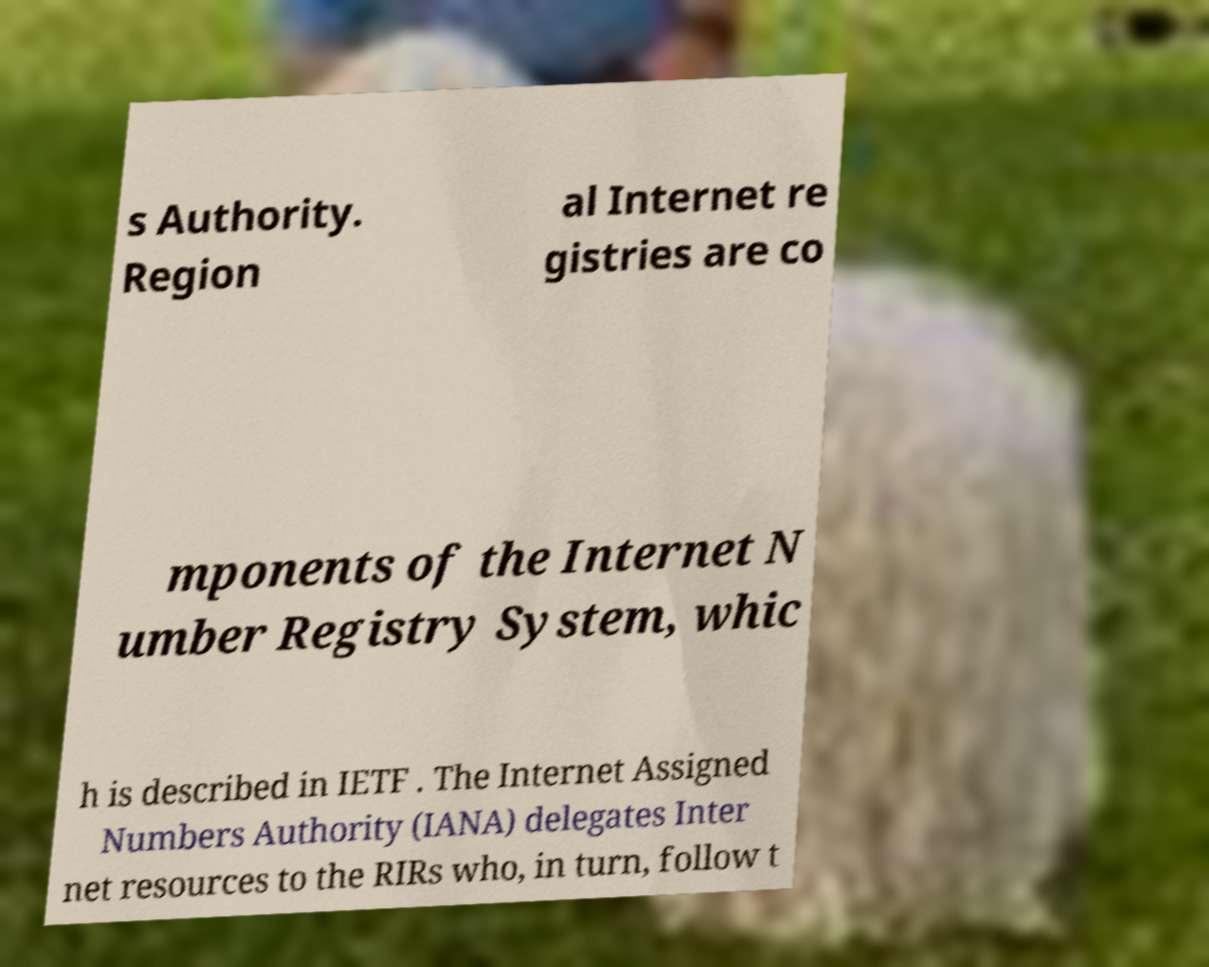Can you read and provide the text displayed in the image?This photo seems to have some interesting text. Can you extract and type it out for me? s Authority. Region al Internet re gistries are co mponents of the Internet N umber Registry System, whic h is described in IETF . The Internet Assigned Numbers Authority (IANA) delegates Inter net resources to the RIRs who, in turn, follow t 